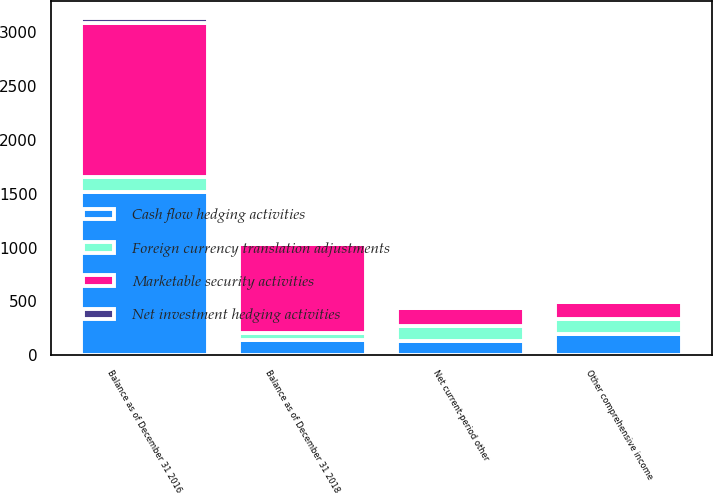<chart> <loc_0><loc_0><loc_500><loc_500><stacked_bar_chart><ecel><fcel>Other comprehensive income<fcel>Net current-period other<fcel>Balance as of December 31 2016<fcel>Balance as of December 31 2018<nl><fcel>Marketable security activities<fcel>165<fcel>165<fcel>1435<fcel>830<nl><fcel>Foreign currency translation adjustments<fcel>140<fcel>140<fcel>140<fcel>65<nl><fcel>Cash flow hedging activities<fcel>194<fcel>135<fcel>1513<fcel>140<nl><fcel>Net investment hedging activities<fcel>7<fcel>1<fcel>46<fcel>10<nl></chart> 